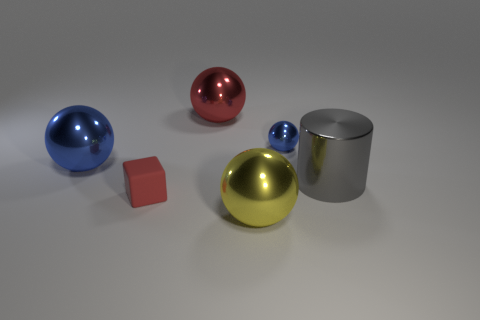Giving the sizes and positions of objects, what might this arrangement symbolize? This arrangement could symbolize balance and contrast. The varying sizes of the balls might represent different strengths or capacities, while the color contrast between the red and blue balls can indicate opposing forces or ideas. The silver cylinder and cube could symbolize stability and structure amidst diversity. 